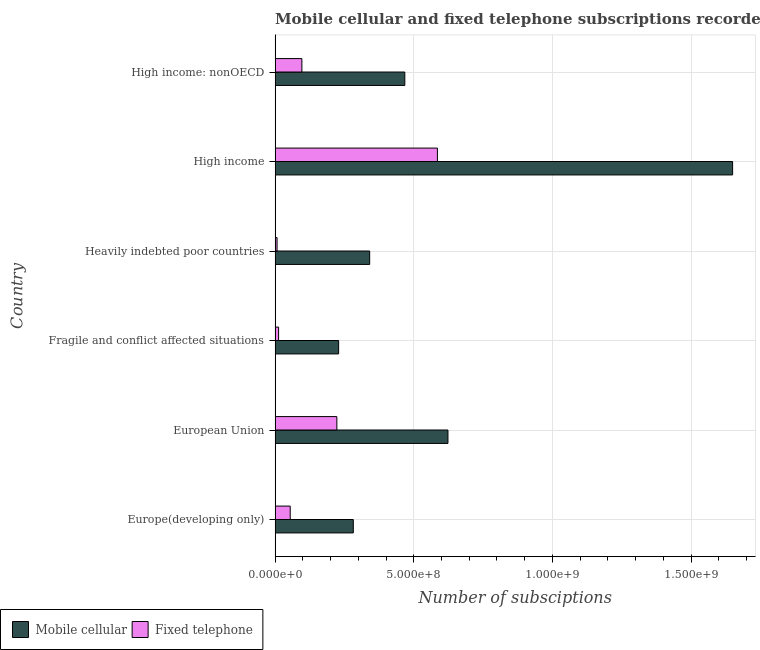How many different coloured bars are there?
Give a very brief answer. 2. How many groups of bars are there?
Offer a terse response. 6. Are the number of bars per tick equal to the number of legend labels?
Your answer should be compact. Yes. How many bars are there on the 1st tick from the top?
Offer a very short reply. 2. In how many cases, is the number of bars for a given country not equal to the number of legend labels?
Give a very brief answer. 0. What is the number of mobile cellular subscriptions in Fragile and conflict affected situations?
Give a very brief answer. 2.29e+08. Across all countries, what is the maximum number of mobile cellular subscriptions?
Provide a succinct answer. 1.65e+09. Across all countries, what is the minimum number of fixed telephone subscriptions?
Offer a very short reply. 7.14e+06. In which country was the number of fixed telephone subscriptions minimum?
Provide a short and direct response. Heavily indebted poor countries. What is the total number of fixed telephone subscriptions in the graph?
Your answer should be compact. 9.79e+08. What is the difference between the number of fixed telephone subscriptions in High income and that in High income: nonOECD?
Provide a short and direct response. 4.89e+08. What is the difference between the number of mobile cellular subscriptions in Europe(developing only) and the number of fixed telephone subscriptions in High income: nonOECD?
Provide a short and direct response. 1.85e+08. What is the average number of mobile cellular subscriptions per country?
Provide a short and direct response. 5.99e+08. What is the difference between the number of fixed telephone subscriptions and number of mobile cellular subscriptions in Europe(developing only)?
Offer a very short reply. -2.27e+08. What is the ratio of the number of fixed telephone subscriptions in European Union to that in Heavily indebted poor countries?
Your answer should be compact. 31.19. What is the difference between the highest and the second highest number of mobile cellular subscriptions?
Ensure brevity in your answer.  1.03e+09. What is the difference between the highest and the lowest number of fixed telephone subscriptions?
Make the answer very short. 5.78e+08. In how many countries, is the number of mobile cellular subscriptions greater than the average number of mobile cellular subscriptions taken over all countries?
Your answer should be very brief. 2. What does the 1st bar from the top in High income: nonOECD represents?
Give a very brief answer. Fixed telephone. What does the 2nd bar from the bottom in Europe(developing only) represents?
Ensure brevity in your answer.  Fixed telephone. Are all the bars in the graph horizontal?
Give a very brief answer. Yes. What is the difference between two consecutive major ticks on the X-axis?
Keep it short and to the point. 5.00e+08. Does the graph contain grids?
Offer a very short reply. Yes. How are the legend labels stacked?
Provide a short and direct response. Horizontal. What is the title of the graph?
Your response must be concise. Mobile cellular and fixed telephone subscriptions recorded in 2012. What is the label or title of the X-axis?
Give a very brief answer. Number of subsciptions. What is the Number of subsciptions in Mobile cellular in Europe(developing only)?
Ensure brevity in your answer.  2.82e+08. What is the Number of subsciptions in Fixed telephone in Europe(developing only)?
Offer a very short reply. 5.46e+07. What is the Number of subsciptions of Mobile cellular in European Union?
Provide a succinct answer. 6.23e+08. What is the Number of subsciptions of Fixed telephone in European Union?
Provide a short and direct response. 2.23e+08. What is the Number of subsciptions of Mobile cellular in Fragile and conflict affected situations?
Your answer should be very brief. 2.29e+08. What is the Number of subsciptions of Fixed telephone in Fragile and conflict affected situations?
Give a very brief answer. 1.27e+07. What is the Number of subsciptions of Mobile cellular in Heavily indebted poor countries?
Provide a short and direct response. 3.41e+08. What is the Number of subsciptions in Fixed telephone in Heavily indebted poor countries?
Your answer should be very brief. 7.14e+06. What is the Number of subsciptions in Mobile cellular in High income?
Make the answer very short. 1.65e+09. What is the Number of subsciptions in Fixed telephone in High income?
Your response must be concise. 5.85e+08. What is the Number of subsciptions of Mobile cellular in High income: nonOECD?
Provide a short and direct response. 4.68e+08. What is the Number of subsciptions in Fixed telephone in High income: nonOECD?
Provide a succinct answer. 9.66e+07. Across all countries, what is the maximum Number of subsciptions in Mobile cellular?
Your answer should be compact. 1.65e+09. Across all countries, what is the maximum Number of subsciptions of Fixed telephone?
Make the answer very short. 5.85e+08. Across all countries, what is the minimum Number of subsciptions of Mobile cellular?
Your answer should be very brief. 2.29e+08. Across all countries, what is the minimum Number of subsciptions of Fixed telephone?
Your answer should be compact. 7.14e+06. What is the total Number of subsciptions in Mobile cellular in the graph?
Your response must be concise. 3.59e+09. What is the total Number of subsciptions in Fixed telephone in the graph?
Your answer should be compact. 9.79e+08. What is the difference between the Number of subsciptions of Mobile cellular in Europe(developing only) and that in European Union?
Your answer should be very brief. -3.41e+08. What is the difference between the Number of subsciptions of Fixed telephone in Europe(developing only) and that in European Union?
Give a very brief answer. -1.68e+08. What is the difference between the Number of subsciptions of Mobile cellular in Europe(developing only) and that in Fragile and conflict affected situations?
Offer a very short reply. 5.29e+07. What is the difference between the Number of subsciptions of Fixed telephone in Europe(developing only) and that in Fragile and conflict affected situations?
Give a very brief answer. 4.19e+07. What is the difference between the Number of subsciptions in Mobile cellular in Europe(developing only) and that in Heavily indebted poor countries?
Make the answer very short. -5.90e+07. What is the difference between the Number of subsciptions in Fixed telephone in Europe(developing only) and that in Heavily indebted poor countries?
Your answer should be compact. 4.74e+07. What is the difference between the Number of subsciptions of Mobile cellular in Europe(developing only) and that in High income?
Provide a short and direct response. -1.37e+09. What is the difference between the Number of subsciptions in Fixed telephone in Europe(developing only) and that in High income?
Keep it short and to the point. -5.31e+08. What is the difference between the Number of subsciptions of Mobile cellular in Europe(developing only) and that in High income: nonOECD?
Offer a very short reply. -1.86e+08. What is the difference between the Number of subsciptions of Fixed telephone in Europe(developing only) and that in High income: nonOECD?
Your answer should be very brief. -4.20e+07. What is the difference between the Number of subsciptions of Mobile cellular in European Union and that in Fragile and conflict affected situations?
Offer a very short reply. 3.94e+08. What is the difference between the Number of subsciptions of Fixed telephone in European Union and that in Fragile and conflict affected situations?
Your answer should be compact. 2.10e+08. What is the difference between the Number of subsciptions in Mobile cellular in European Union and that in Heavily indebted poor countries?
Ensure brevity in your answer.  2.82e+08. What is the difference between the Number of subsciptions in Fixed telephone in European Union and that in Heavily indebted poor countries?
Make the answer very short. 2.16e+08. What is the difference between the Number of subsciptions in Mobile cellular in European Union and that in High income?
Ensure brevity in your answer.  -1.03e+09. What is the difference between the Number of subsciptions of Fixed telephone in European Union and that in High income?
Give a very brief answer. -3.62e+08. What is the difference between the Number of subsciptions in Mobile cellular in European Union and that in High income: nonOECD?
Provide a short and direct response. 1.56e+08. What is the difference between the Number of subsciptions of Fixed telephone in European Union and that in High income: nonOECD?
Offer a terse response. 1.26e+08. What is the difference between the Number of subsciptions in Mobile cellular in Fragile and conflict affected situations and that in Heavily indebted poor countries?
Provide a short and direct response. -1.12e+08. What is the difference between the Number of subsciptions of Fixed telephone in Fragile and conflict affected situations and that in Heavily indebted poor countries?
Provide a short and direct response. 5.52e+06. What is the difference between the Number of subsciptions in Mobile cellular in Fragile and conflict affected situations and that in High income?
Your answer should be compact. -1.42e+09. What is the difference between the Number of subsciptions in Fixed telephone in Fragile and conflict affected situations and that in High income?
Your answer should be compact. -5.73e+08. What is the difference between the Number of subsciptions in Mobile cellular in Fragile and conflict affected situations and that in High income: nonOECD?
Your response must be concise. -2.39e+08. What is the difference between the Number of subsciptions of Fixed telephone in Fragile and conflict affected situations and that in High income: nonOECD?
Offer a terse response. -8.39e+07. What is the difference between the Number of subsciptions of Mobile cellular in Heavily indebted poor countries and that in High income?
Provide a succinct answer. -1.31e+09. What is the difference between the Number of subsciptions in Fixed telephone in Heavily indebted poor countries and that in High income?
Provide a short and direct response. -5.78e+08. What is the difference between the Number of subsciptions of Mobile cellular in Heavily indebted poor countries and that in High income: nonOECD?
Your response must be concise. -1.27e+08. What is the difference between the Number of subsciptions in Fixed telephone in Heavily indebted poor countries and that in High income: nonOECD?
Provide a succinct answer. -8.95e+07. What is the difference between the Number of subsciptions in Mobile cellular in High income and that in High income: nonOECD?
Provide a short and direct response. 1.18e+09. What is the difference between the Number of subsciptions of Fixed telephone in High income and that in High income: nonOECD?
Your response must be concise. 4.89e+08. What is the difference between the Number of subsciptions in Mobile cellular in Europe(developing only) and the Number of subsciptions in Fixed telephone in European Union?
Provide a succinct answer. 5.92e+07. What is the difference between the Number of subsciptions of Mobile cellular in Europe(developing only) and the Number of subsciptions of Fixed telephone in Fragile and conflict affected situations?
Your answer should be very brief. 2.69e+08. What is the difference between the Number of subsciptions in Mobile cellular in Europe(developing only) and the Number of subsciptions in Fixed telephone in Heavily indebted poor countries?
Provide a succinct answer. 2.75e+08. What is the difference between the Number of subsciptions in Mobile cellular in Europe(developing only) and the Number of subsciptions in Fixed telephone in High income?
Give a very brief answer. -3.03e+08. What is the difference between the Number of subsciptions in Mobile cellular in Europe(developing only) and the Number of subsciptions in Fixed telephone in High income: nonOECD?
Provide a short and direct response. 1.85e+08. What is the difference between the Number of subsciptions of Mobile cellular in European Union and the Number of subsciptions of Fixed telephone in Fragile and conflict affected situations?
Your response must be concise. 6.11e+08. What is the difference between the Number of subsciptions of Mobile cellular in European Union and the Number of subsciptions of Fixed telephone in Heavily indebted poor countries?
Give a very brief answer. 6.16e+08. What is the difference between the Number of subsciptions in Mobile cellular in European Union and the Number of subsciptions in Fixed telephone in High income?
Offer a terse response. 3.81e+07. What is the difference between the Number of subsciptions in Mobile cellular in European Union and the Number of subsciptions in Fixed telephone in High income: nonOECD?
Your answer should be very brief. 5.27e+08. What is the difference between the Number of subsciptions in Mobile cellular in Fragile and conflict affected situations and the Number of subsciptions in Fixed telephone in Heavily indebted poor countries?
Offer a very short reply. 2.22e+08. What is the difference between the Number of subsciptions of Mobile cellular in Fragile and conflict affected situations and the Number of subsciptions of Fixed telephone in High income?
Your response must be concise. -3.56e+08. What is the difference between the Number of subsciptions in Mobile cellular in Fragile and conflict affected situations and the Number of subsciptions in Fixed telephone in High income: nonOECD?
Provide a succinct answer. 1.32e+08. What is the difference between the Number of subsciptions of Mobile cellular in Heavily indebted poor countries and the Number of subsciptions of Fixed telephone in High income?
Provide a succinct answer. -2.44e+08. What is the difference between the Number of subsciptions in Mobile cellular in Heavily indebted poor countries and the Number of subsciptions in Fixed telephone in High income: nonOECD?
Offer a terse response. 2.44e+08. What is the difference between the Number of subsciptions in Mobile cellular in High income and the Number of subsciptions in Fixed telephone in High income: nonOECD?
Offer a terse response. 1.55e+09. What is the average Number of subsciptions of Mobile cellular per country?
Offer a very short reply. 5.99e+08. What is the average Number of subsciptions of Fixed telephone per country?
Provide a short and direct response. 1.63e+08. What is the difference between the Number of subsciptions in Mobile cellular and Number of subsciptions in Fixed telephone in Europe(developing only)?
Make the answer very short. 2.27e+08. What is the difference between the Number of subsciptions in Mobile cellular and Number of subsciptions in Fixed telephone in European Union?
Give a very brief answer. 4.01e+08. What is the difference between the Number of subsciptions of Mobile cellular and Number of subsciptions of Fixed telephone in Fragile and conflict affected situations?
Make the answer very short. 2.16e+08. What is the difference between the Number of subsciptions in Mobile cellular and Number of subsciptions in Fixed telephone in Heavily indebted poor countries?
Keep it short and to the point. 3.34e+08. What is the difference between the Number of subsciptions in Mobile cellular and Number of subsciptions in Fixed telephone in High income?
Your response must be concise. 1.06e+09. What is the difference between the Number of subsciptions in Mobile cellular and Number of subsciptions in Fixed telephone in High income: nonOECD?
Your response must be concise. 3.71e+08. What is the ratio of the Number of subsciptions in Mobile cellular in Europe(developing only) to that in European Union?
Give a very brief answer. 0.45. What is the ratio of the Number of subsciptions in Fixed telephone in Europe(developing only) to that in European Union?
Make the answer very short. 0.24. What is the ratio of the Number of subsciptions in Mobile cellular in Europe(developing only) to that in Fragile and conflict affected situations?
Your response must be concise. 1.23. What is the ratio of the Number of subsciptions of Fixed telephone in Europe(developing only) to that in Fragile and conflict affected situations?
Give a very brief answer. 4.31. What is the ratio of the Number of subsciptions in Mobile cellular in Europe(developing only) to that in Heavily indebted poor countries?
Provide a succinct answer. 0.83. What is the ratio of the Number of subsciptions in Fixed telephone in Europe(developing only) to that in Heavily indebted poor countries?
Your answer should be compact. 7.64. What is the ratio of the Number of subsciptions of Mobile cellular in Europe(developing only) to that in High income?
Your answer should be very brief. 0.17. What is the ratio of the Number of subsciptions of Fixed telephone in Europe(developing only) to that in High income?
Provide a short and direct response. 0.09. What is the ratio of the Number of subsciptions in Mobile cellular in Europe(developing only) to that in High income: nonOECD?
Your answer should be very brief. 0.6. What is the ratio of the Number of subsciptions of Fixed telephone in Europe(developing only) to that in High income: nonOECD?
Keep it short and to the point. 0.56. What is the ratio of the Number of subsciptions in Mobile cellular in European Union to that in Fragile and conflict affected situations?
Offer a terse response. 2.72. What is the ratio of the Number of subsciptions of Fixed telephone in European Union to that in Fragile and conflict affected situations?
Your answer should be very brief. 17.59. What is the ratio of the Number of subsciptions in Mobile cellular in European Union to that in Heavily indebted poor countries?
Ensure brevity in your answer.  1.83. What is the ratio of the Number of subsciptions of Fixed telephone in European Union to that in Heavily indebted poor countries?
Offer a terse response. 31.19. What is the ratio of the Number of subsciptions of Mobile cellular in European Union to that in High income?
Offer a very short reply. 0.38. What is the ratio of the Number of subsciptions in Fixed telephone in European Union to that in High income?
Your answer should be compact. 0.38. What is the ratio of the Number of subsciptions of Mobile cellular in European Union to that in High income: nonOECD?
Make the answer very short. 1.33. What is the ratio of the Number of subsciptions of Fixed telephone in European Union to that in High income: nonOECD?
Your response must be concise. 2.31. What is the ratio of the Number of subsciptions of Mobile cellular in Fragile and conflict affected situations to that in Heavily indebted poor countries?
Offer a very short reply. 0.67. What is the ratio of the Number of subsciptions of Fixed telephone in Fragile and conflict affected situations to that in Heavily indebted poor countries?
Offer a terse response. 1.77. What is the ratio of the Number of subsciptions of Mobile cellular in Fragile and conflict affected situations to that in High income?
Ensure brevity in your answer.  0.14. What is the ratio of the Number of subsciptions in Fixed telephone in Fragile and conflict affected situations to that in High income?
Provide a succinct answer. 0.02. What is the ratio of the Number of subsciptions of Mobile cellular in Fragile and conflict affected situations to that in High income: nonOECD?
Your answer should be compact. 0.49. What is the ratio of the Number of subsciptions of Fixed telephone in Fragile and conflict affected situations to that in High income: nonOECD?
Your answer should be compact. 0.13. What is the ratio of the Number of subsciptions of Mobile cellular in Heavily indebted poor countries to that in High income?
Keep it short and to the point. 0.21. What is the ratio of the Number of subsciptions of Fixed telephone in Heavily indebted poor countries to that in High income?
Provide a succinct answer. 0.01. What is the ratio of the Number of subsciptions in Mobile cellular in Heavily indebted poor countries to that in High income: nonOECD?
Keep it short and to the point. 0.73. What is the ratio of the Number of subsciptions of Fixed telephone in Heavily indebted poor countries to that in High income: nonOECD?
Offer a very short reply. 0.07. What is the ratio of the Number of subsciptions in Mobile cellular in High income to that in High income: nonOECD?
Your answer should be very brief. 3.53. What is the ratio of the Number of subsciptions of Fixed telephone in High income to that in High income: nonOECD?
Offer a terse response. 6.06. What is the difference between the highest and the second highest Number of subsciptions in Mobile cellular?
Provide a short and direct response. 1.03e+09. What is the difference between the highest and the second highest Number of subsciptions of Fixed telephone?
Give a very brief answer. 3.62e+08. What is the difference between the highest and the lowest Number of subsciptions in Mobile cellular?
Give a very brief answer. 1.42e+09. What is the difference between the highest and the lowest Number of subsciptions of Fixed telephone?
Keep it short and to the point. 5.78e+08. 